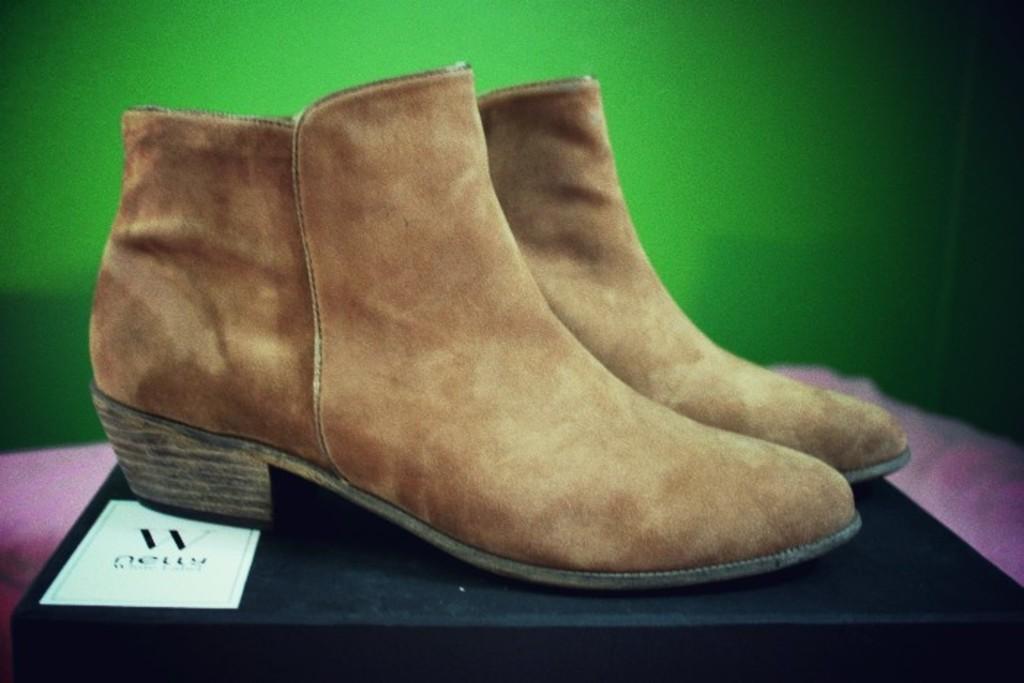How would you summarize this image in a sentence or two? In the foreground of the picture we can see shoes on a box. In the background it is green. 